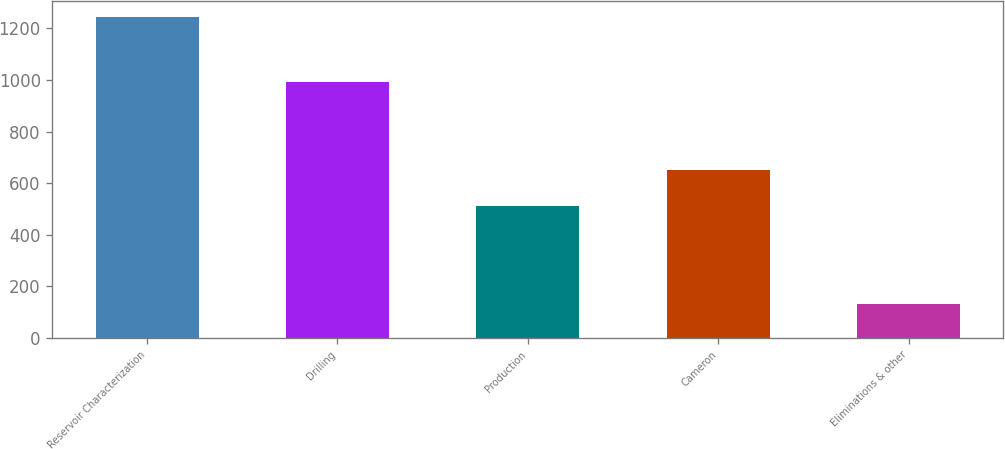Convert chart. <chart><loc_0><loc_0><loc_500><loc_500><bar_chart><fcel>Reservoir Characterization<fcel>Drilling<fcel>Production<fcel>Cameron<fcel>Eliminations & other<nl><fcel>1244<fcel>994<fcel>512<fcel>653<fcel>130<nl></chart> 